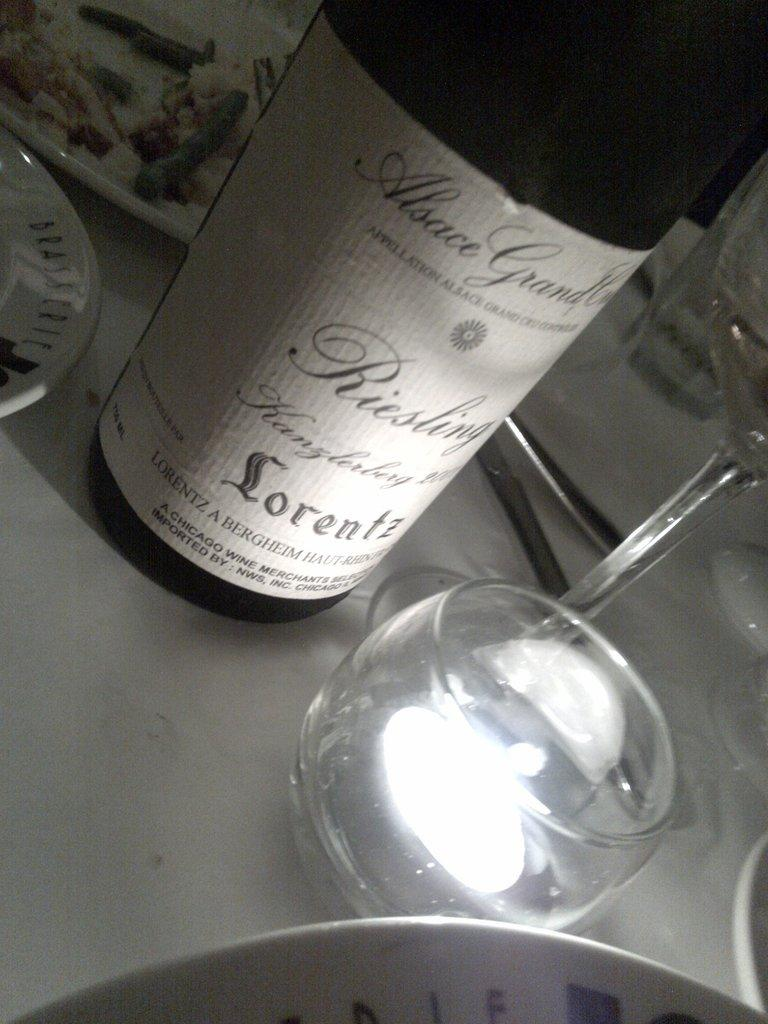<image>
Present a compact description of the photo's key features. bottle of Riesling sits on a dining table. 